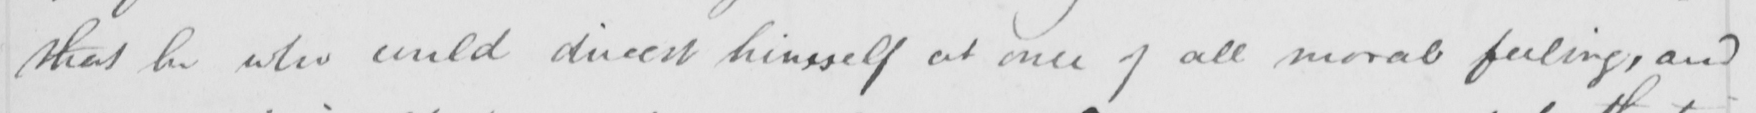What text is written in this handwritten line? that he who could divest himself at once of all moral feeling , and 